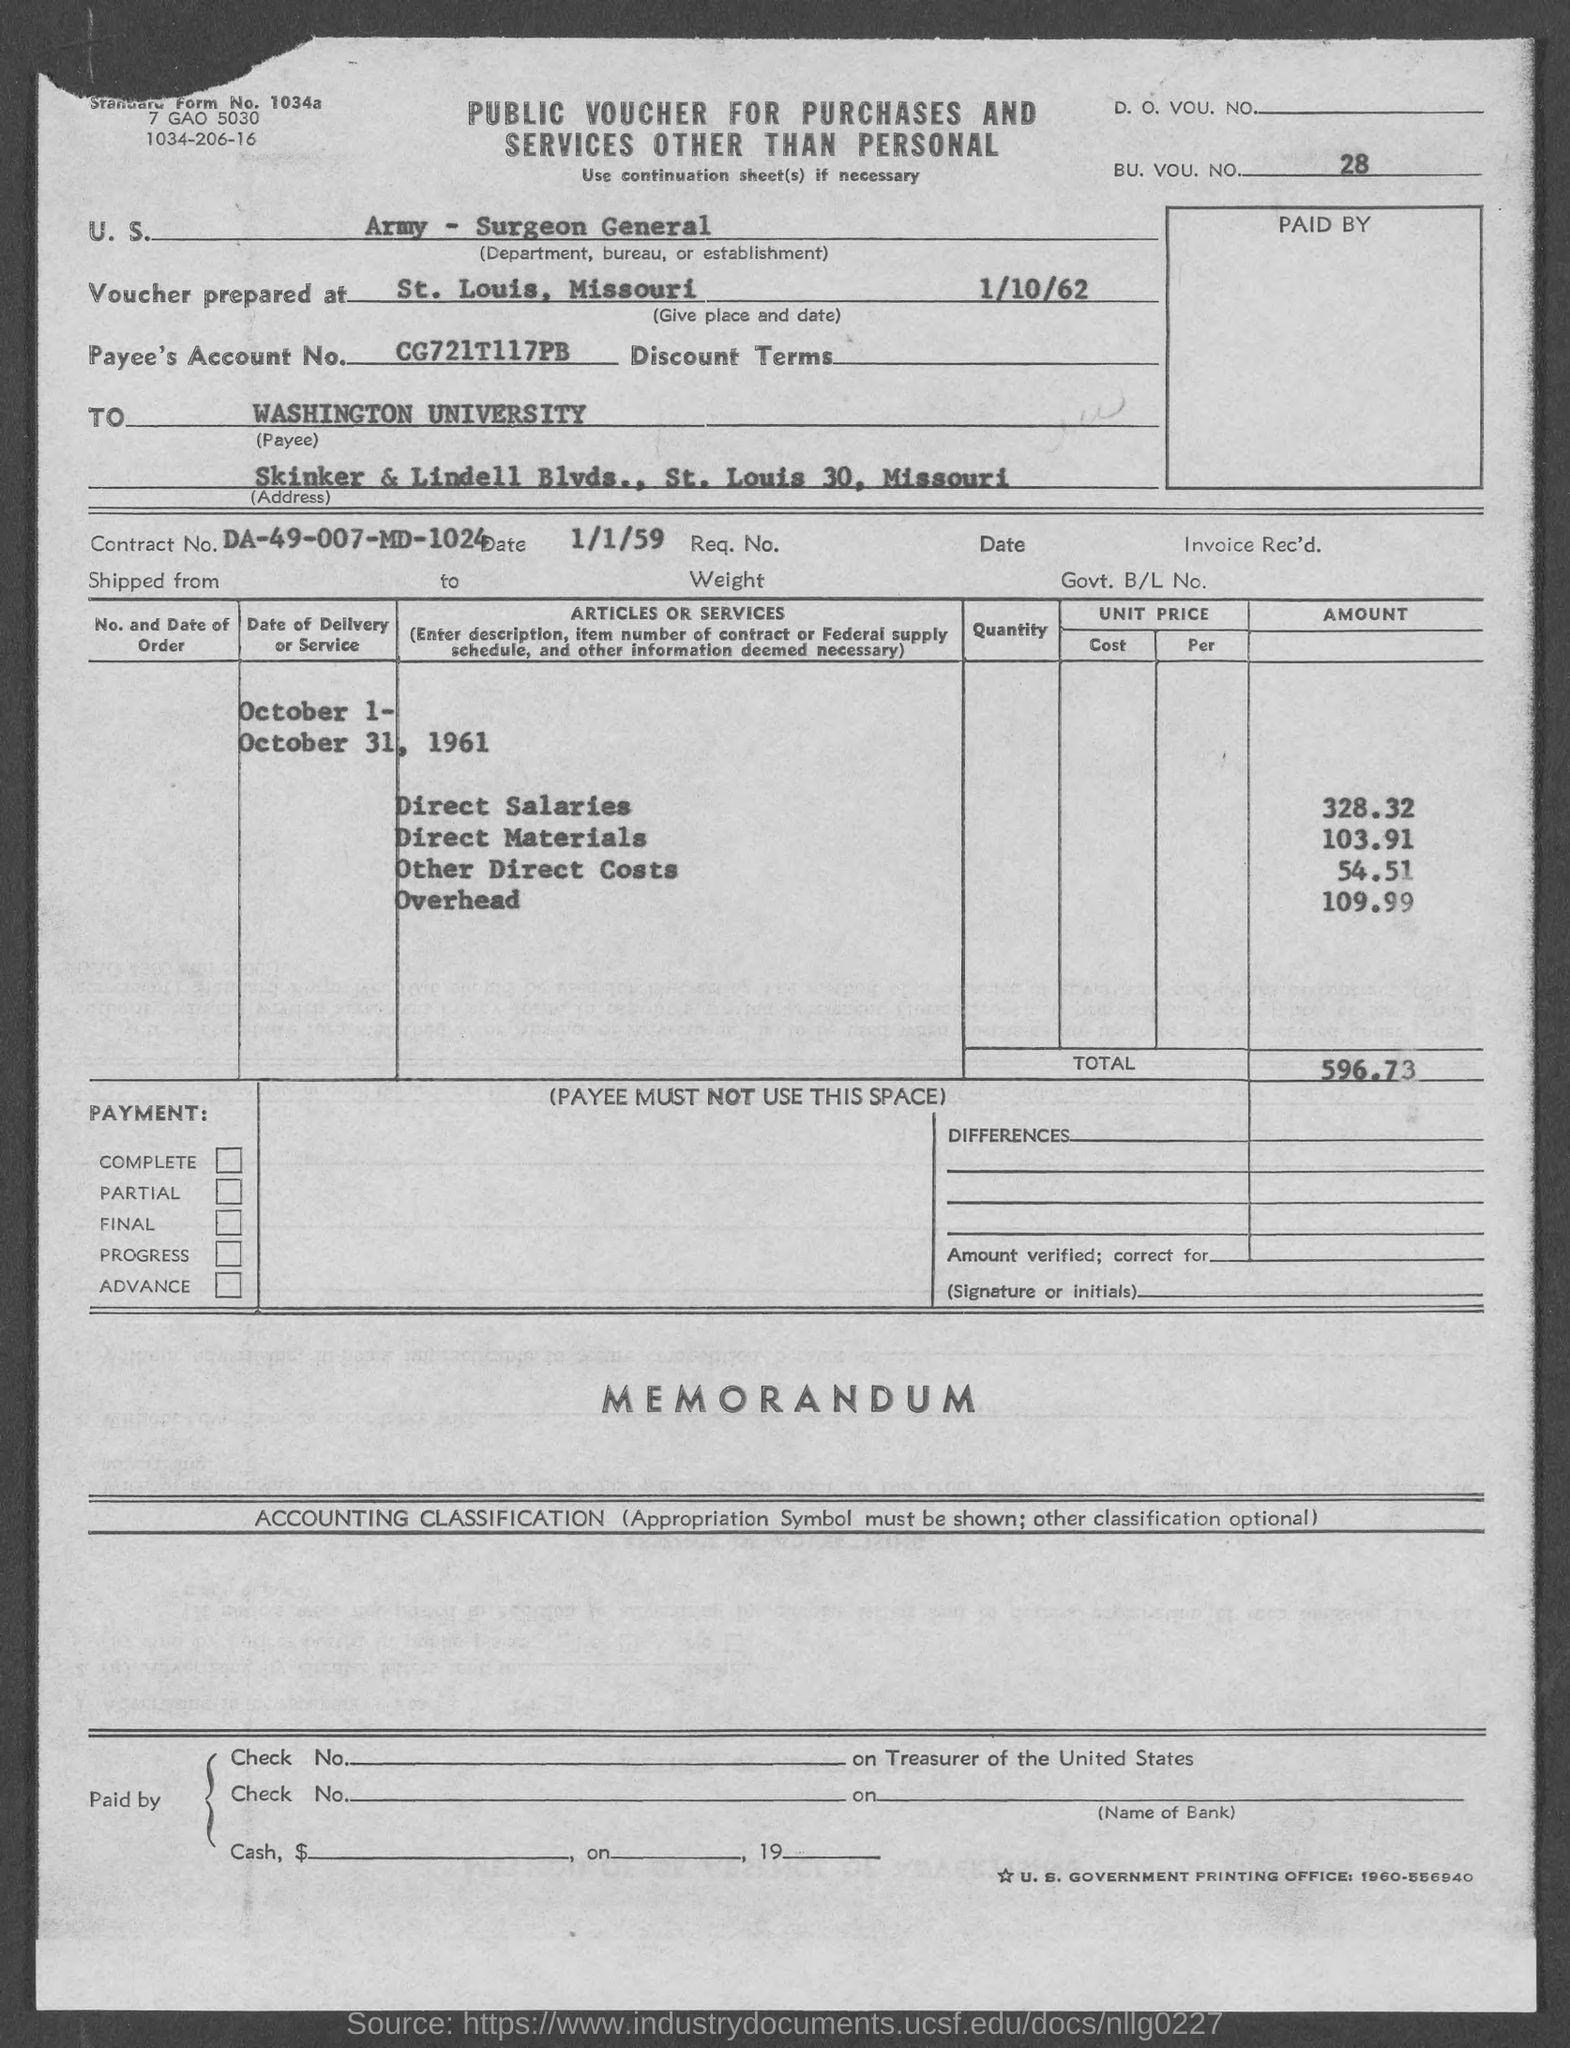What is the voucher prepared date mentioned in the given form ?
Offer a terse response. 1/10/62. Where is the voucher prepared ?
Your response must be concise. St. louis , missouri. What is the payee's account no. mentioned in the given form ?
Offer a very short reply. CG721T117PB. What is the contract no. mentioned in the given form ?
Your response must be concise. DA-49-007-MD-1024. What is the total amount mentioned in the given form ?
Offer a terse response. 596.73. What is the amount of direct salaries as mentioned in the given form ?
Your answer should be compact. 328.32. What is the amount of direct materials mentioned in the given page ?
Provide a succinct answer. 103.91. What is the amount for other direct costs as mentioned in the given form ?
Provide a short and direct response. 54.51. What is the amount for overhead mentioned in the given form ?
Ensure brevity in your answer.  109.99. 